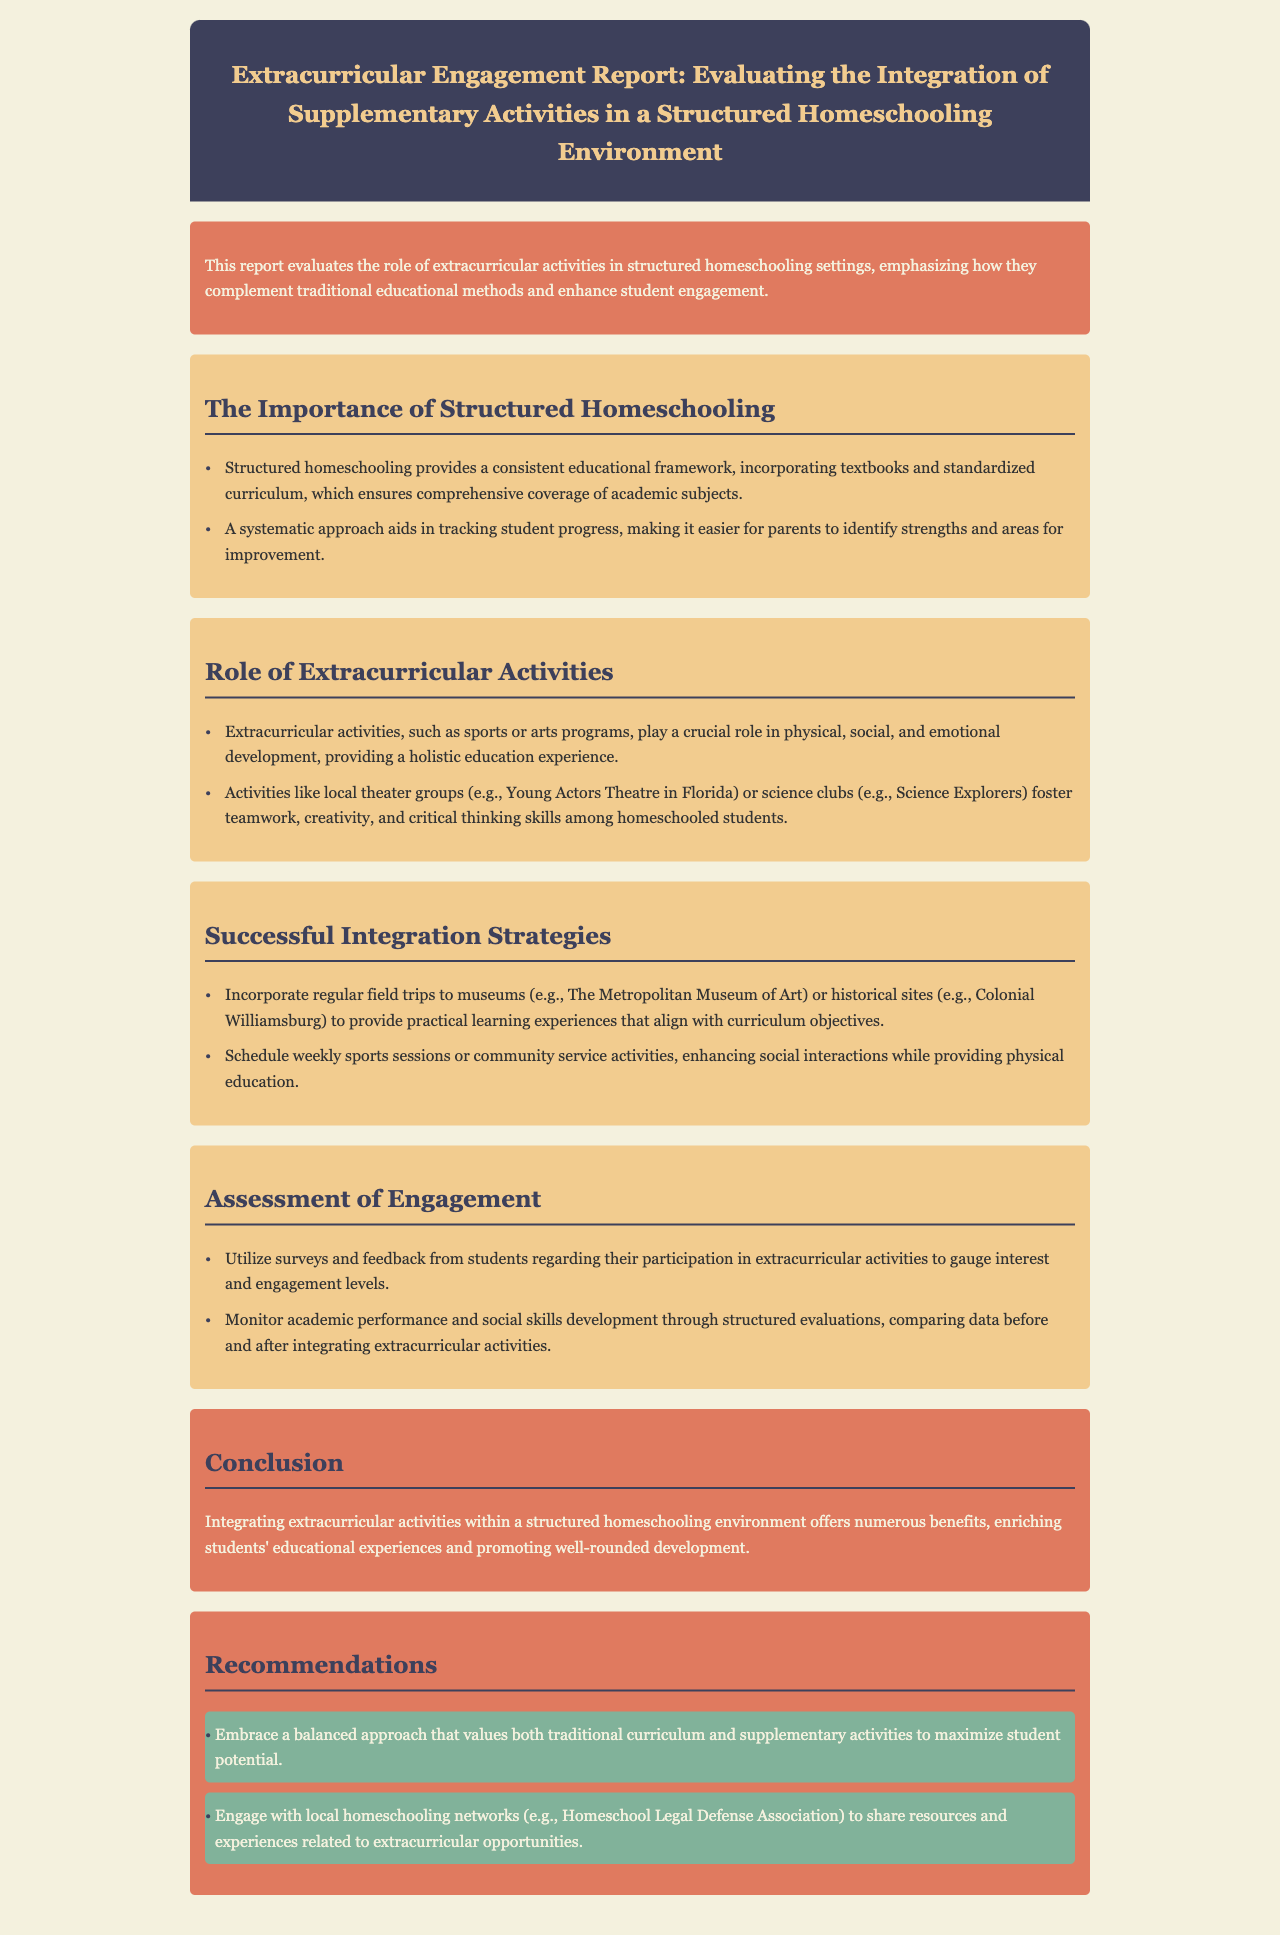What is the title of the report? The title of the report is clearly stated in the header section.
Answer: Extracurricular Engagement Report: Evaluating the Integration of Supplementary Activities in a Structured Homeschooling Environment What does structured homeschooling ensure? The document outlines the benefits of structured homeschooling in the first section.
Answer: Comprehensive coverage of academic subjects Which extracurricular activity is mentioned as fostering teamwork? The report cites specific examples of extracurricular activities in the second section.
Answer: Local theater groups What is a recommended activity to enhance social interactions? The recommendations in the last section suggest specific activities for social engagement.
Answer: Weekly sports sessions How can student engagement be assessed? The assessment of engagement section provides methods for evaluating participation in activities.
Answer: Surveys and feedback What is a primary goal of integrating extracurricular activities? The conclusion highlights the benefits of integrating these activities into homeschooling.
Answer: Promoting well-rounded development What network is mentioned for sharing extracurricular resources? The recommendations section includes a local network that can provide support to homeschoolers.
Answer: Homeschool Legal Defense Association What type of education does structured homeschooling provide? The introduction explains the nature of education within structured homeschooling.
Answer: Traditional educational methods 